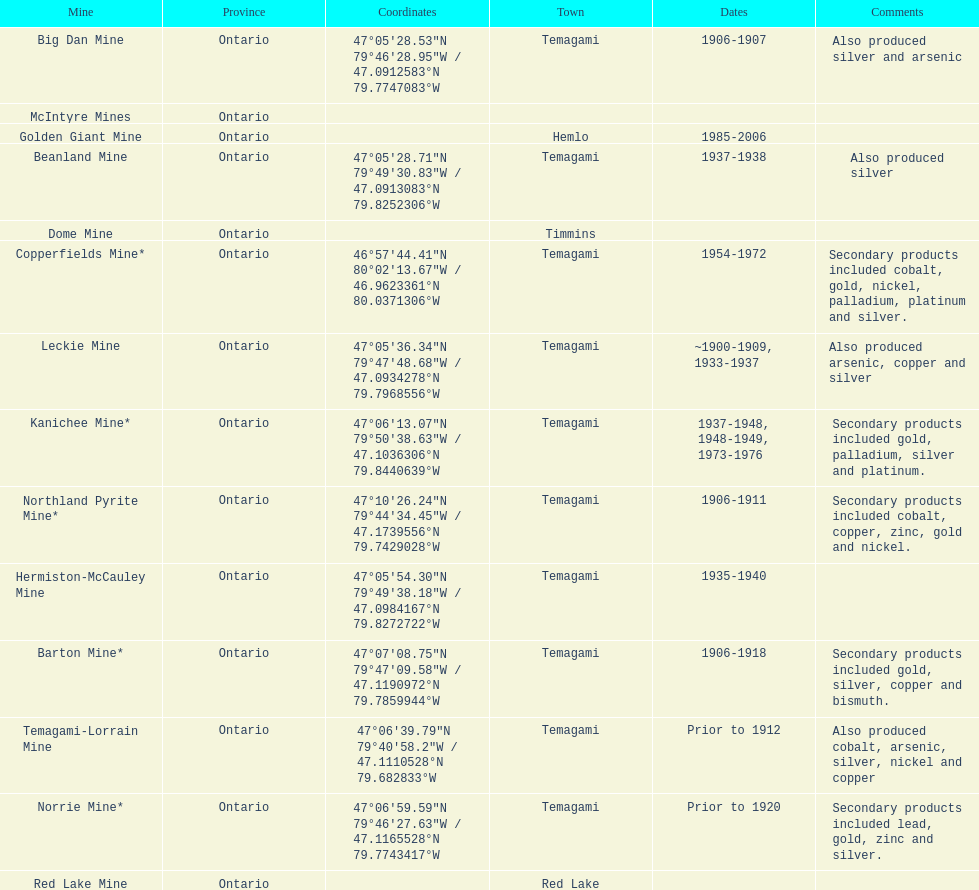Name a gold mine that was open at least 10 years. Barton Mine. 